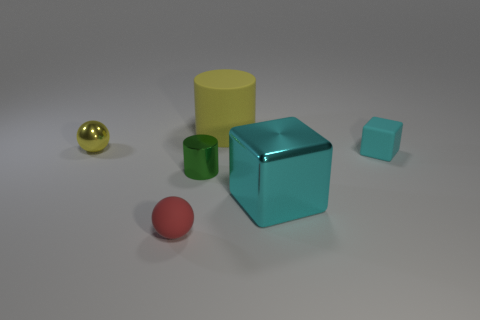Add 2 red things. How many objects exist? 8 Subtract all yellow cylinders. How many cylinders are left? 1 Subtract all tiny green objects. Subtract all tiny rubber balls. How many objects are left? 4 Add 6 red balls. How many red balls are left? 7 Add 4 small purple metal cylinders. How many small purple metal cylinders exist? 4 Subtract 0 gray cubes. How many objects are left? 6 Subtract all cylinders. How many objects are left? 4 Subtract 1 cylinders. How many cylinders are left? 1 Subtract all red cubes. Subtract all green spheres. How many cubes are left? 2 Subtract all cyan cubes. How many yellow cylinders are left? 1 